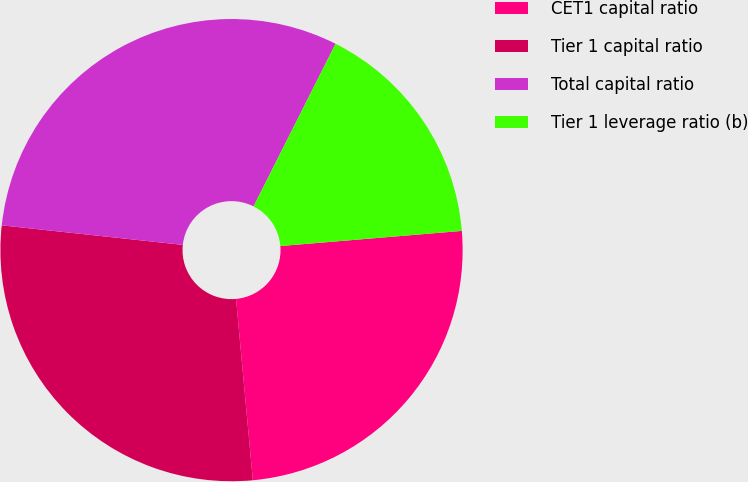<chart> <loc_0><loc_0><loc_500><loc_500><pie_chart><fcel>CET1 capital ratio<fcel>Tier 1 capital ratio<fcel>Total capital ratio<fcel>Tier 1 leverage ratio (b)<nl><fcel>24.85%<fcel>28.18%<fcel>30.72%<fcel>16.24%<nl></chart> 